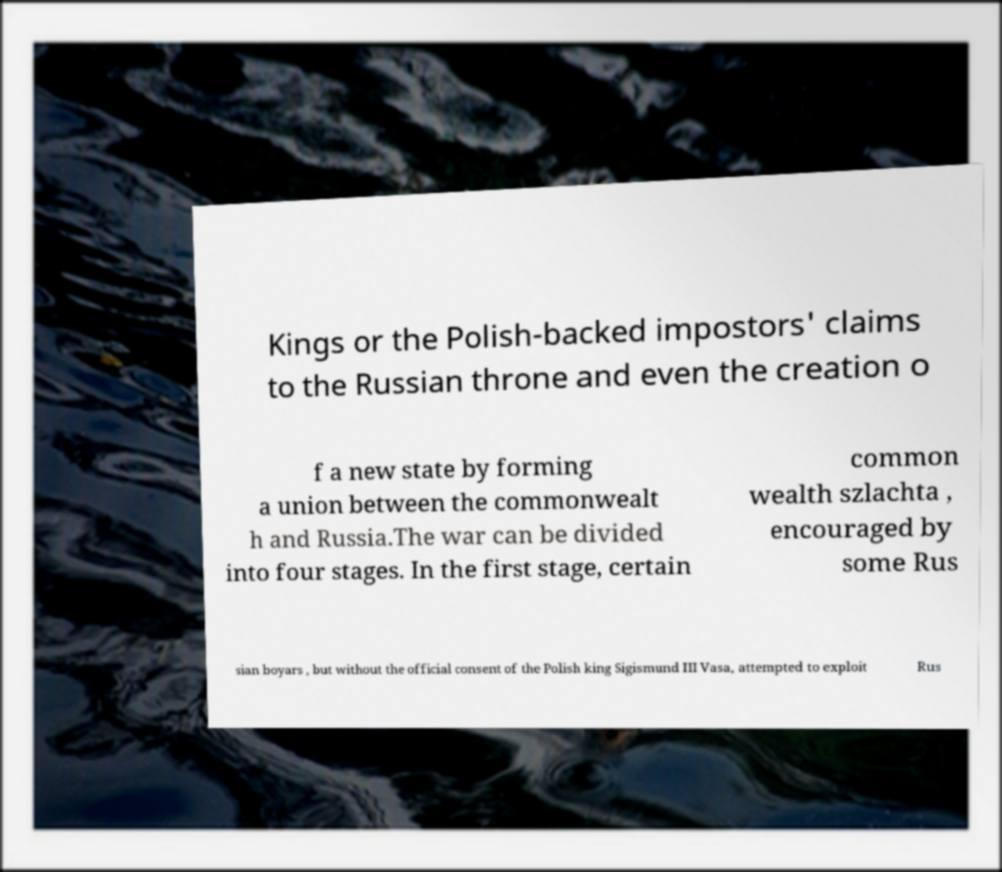For documentation purposes, I need the text within this image transcribed. Could you provide that? Kings or the Polish-backed impostors' claims to the Russian throne and even the creation o f a new state by forming a union between the commonwealt h and Russia.The war can be divided into four stages. In the first stage, certain common wealth szlachta , encouraged by some Rus sian boyars , but without the official consent of the Polish king Sigismund III Vasa, attempted to exploit Rus 